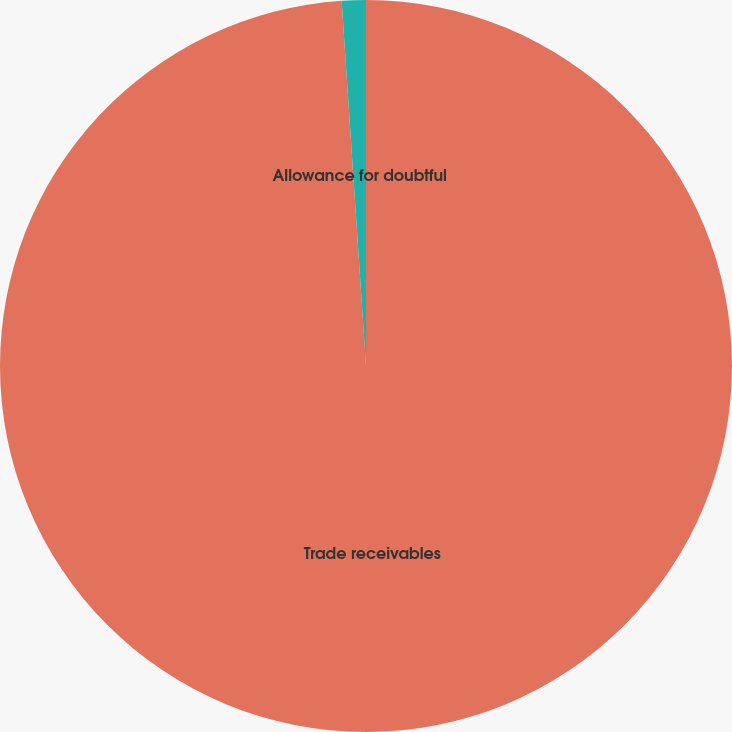Convert chart. <chart><loc_0><loc_0><loc_500><loc_500><pie_chart><fcel>Trade receivables<fcel>Allowance for doubtful<nl><fcel>98.94%<fcel>1.06%<nl></chart> 